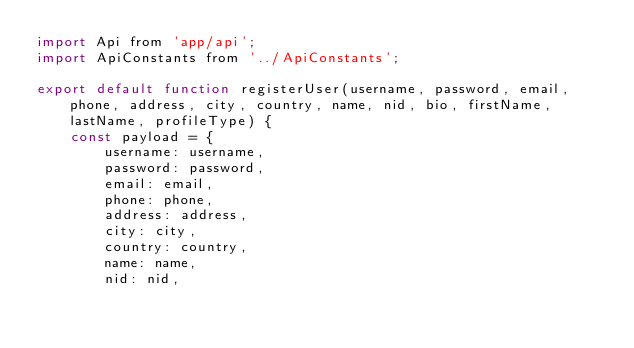Convert code to text. <code><loc_0><loc_0><loc_500><loc_500><_JavaScript_>import Api from 'app/api';
import ApiConstants from '../ApiConstants';

export default function registerUser(username, password, email, phone, address, city, country, name, nid, bio, firstName, lastName, profileType) {
    const payload = {
        username: username, 
        password: password, 
        email: email, 
        phone: phone,
        address: address,
        city: city,
        country: country,
        name: name,
        nid: nid,</code> 